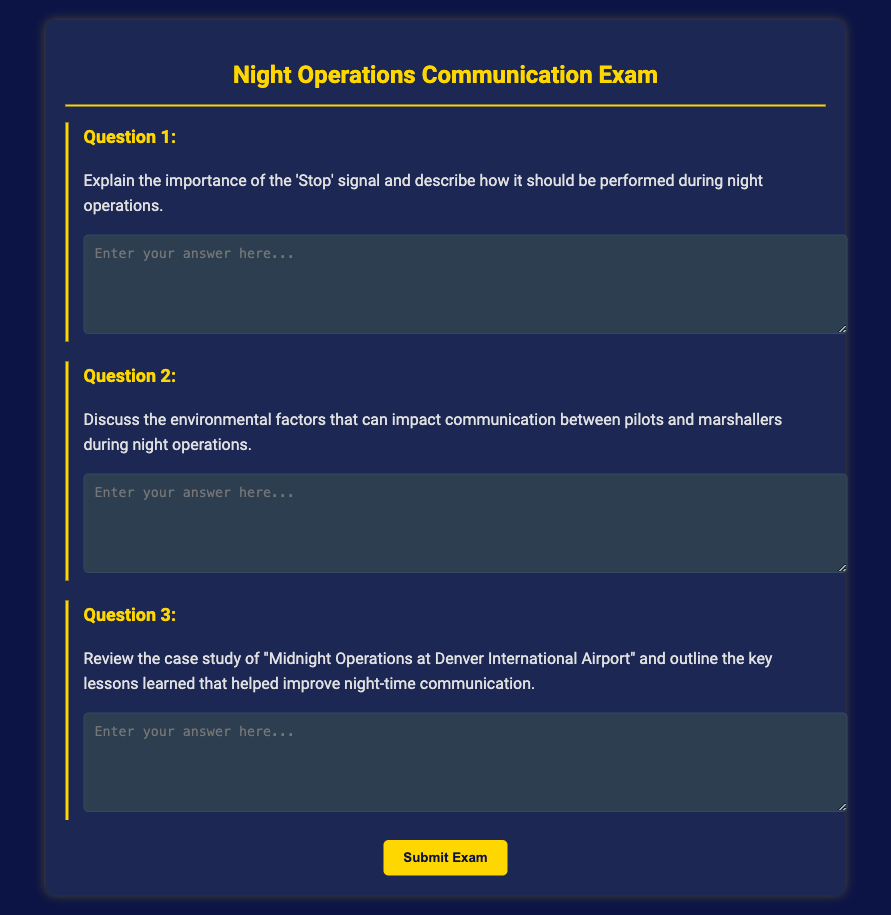what is the title of the document? The title of the document is presented prominently at the top of the page, indicating the subject matter.
Answer: Night Operations Communication Exam how many questions are in the exam? The exam consists of three distinct questions, each focusing on different aspects of communication during night operations.
Answer: 3 what color is the text in the document? The text throughout the document is styled to be visually appealing, specifically described by the chosen color in the CSS.
Answer: #e0e0e0 what is the purpose of the 'Stop' signal? The importance of the 'Stop' signal is a key focus of the first question, which asks for an explanation of its role during night operations.
Answer: Safety what background color is used for the exam container? The color scheme for the exam container is detailed within the style section of the document's code, describing its appearance.
Answer: #1c2754 what environmental factor is discussed in Question 2? The second question invites discussion about the impact of specific external circumstances on communication between pilots and marshallers.
Answer: Environmental factors what is the key focus of Question 3? The third question prompts the review of a specific case study, encouraging the outline of lessons learned from that scenario.
Answer: Lessons learned when should the submit button be clicked? The submit button is intended to be clicked once the candidate has completed all questions in the exam form.
Answer: After answering how is the submit button styled? The styling of the submit button is defined with particular specifications for its appearance and interactivity.
Answer: #ffd700 